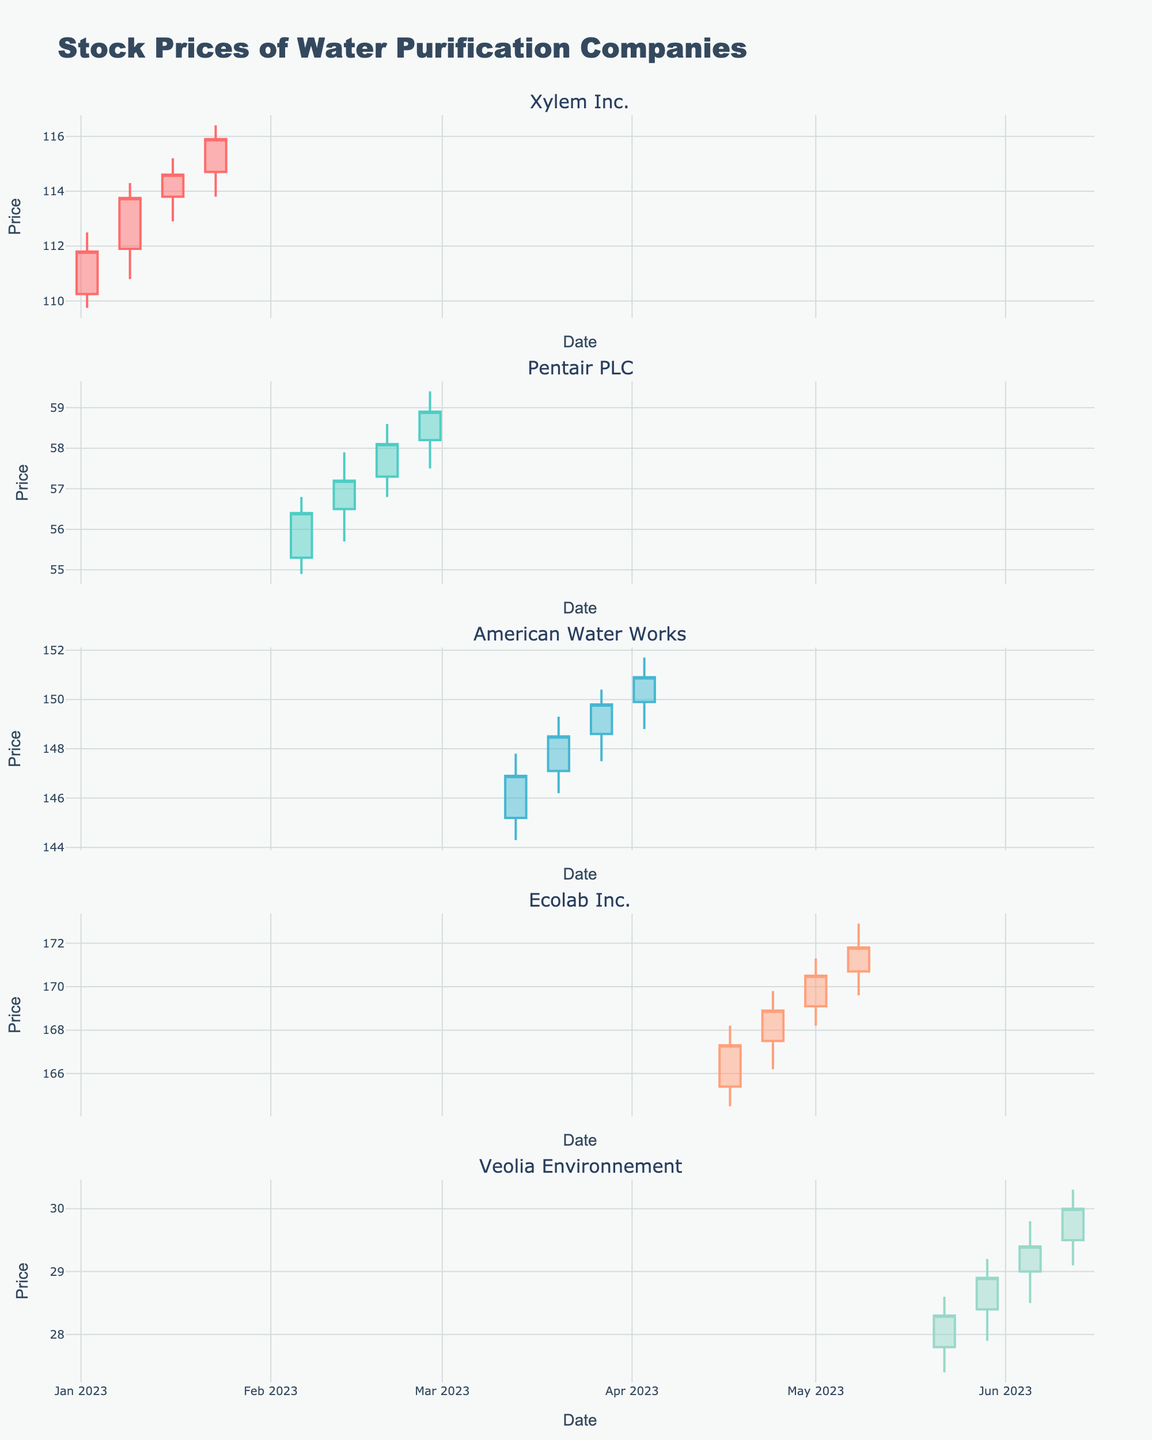What is the title of the figure? The title appears at the top of the figure and it's labeled as "Stock Prices of Water Purification Companies".
Answer: Stock Prices of Water Purification Companies Which company's stock has the highest closing price in the timeframe shown? By observing the charts, American Water Works has the highest closing price within the timeframe, reaching $150.90 on 2023-04-03.
Answer: American Water Works What is the color of the increasing line for Xylem Inc.? The increasing line color for Xylem Inc. is identified by observing the color of the candlesticks in the Xylem Inc. plot when the stock closes higher than it opened.
Answer: Light Red (approx: #FF6B6B) How many companies are shown in the figure? There are five subplot titles in the figure, each representing a different company's stock price.
Answer: Five For how many weeks does the data for Ecolab Inc. show price movements? Ecolab Inc.'s chart shows price movements for four weeks, each represented by one candlestick.
Answer: Four What was the closing price for Pentair PLC on 2023-02-20? By locating the week of 2023-02-20 in the plot for Pentair PLC, the closing price is shown as $58.10.
Answer: $58.10 Compare the closing prices of Xylem Inc. and Pentair PLC in their respective first weeks shown. Which company has a higher closing price? To compare, check Xylem Inc.'s first week closing price ($111.80 on 2023-01-02) and Pentair PLC's first week closing price ($56.40 on 2023-02-06). Xylem Inc.'s closing price is higher.
Answer: Xylem Inc Which company had the smallest weekly price range (difference between High and Low) and what was it? By checking each candlestick's high and low prices for each company, Veolia Environnement had the smallest weekly price range of $0.90 ($27.90 to $28.80) in the week starting 2023-05-22.
Answer: Veolia Environnement, $0.90 What was the total range of stock prices (difference between the highest High and the lowest Low) for American Water Works? The highest High for American Water Works was $151.70, and the lowest Low was $144.30, giving a total range of $151.70 - $144.30 = $7.40.
Answer: $7.40 Which company had a consistent increase in closing prices over four consecutive weeks, and what was the increase? Ecolab Inc. had consistent weekly closing price increases from 2023-04-17 ($167.30) to 2023-05-08 ($171.80). The increase can be computed as $171.80 - $167.30 = $4.50.
Answer: Ecolab Inc., $4.50 